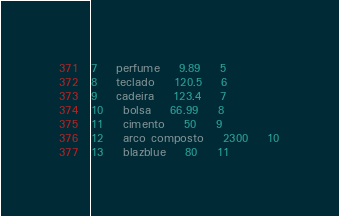<code> <loc_0><loc_0><loc_500><loc_500><_SQL_>7	perfume	9.89	5
8	teclado	120.5	6
9	cadeira	123.4	7
10	bolsa	66.99	8
11	cimento	50	9
12	arco composto	2300	10
13	blazblue	80	11
</code> 